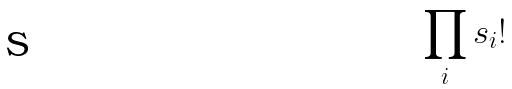<formula> <loc_0><loc_0><loc_500><loc_500>\prod _ { i } s _ { i } !</formula> 